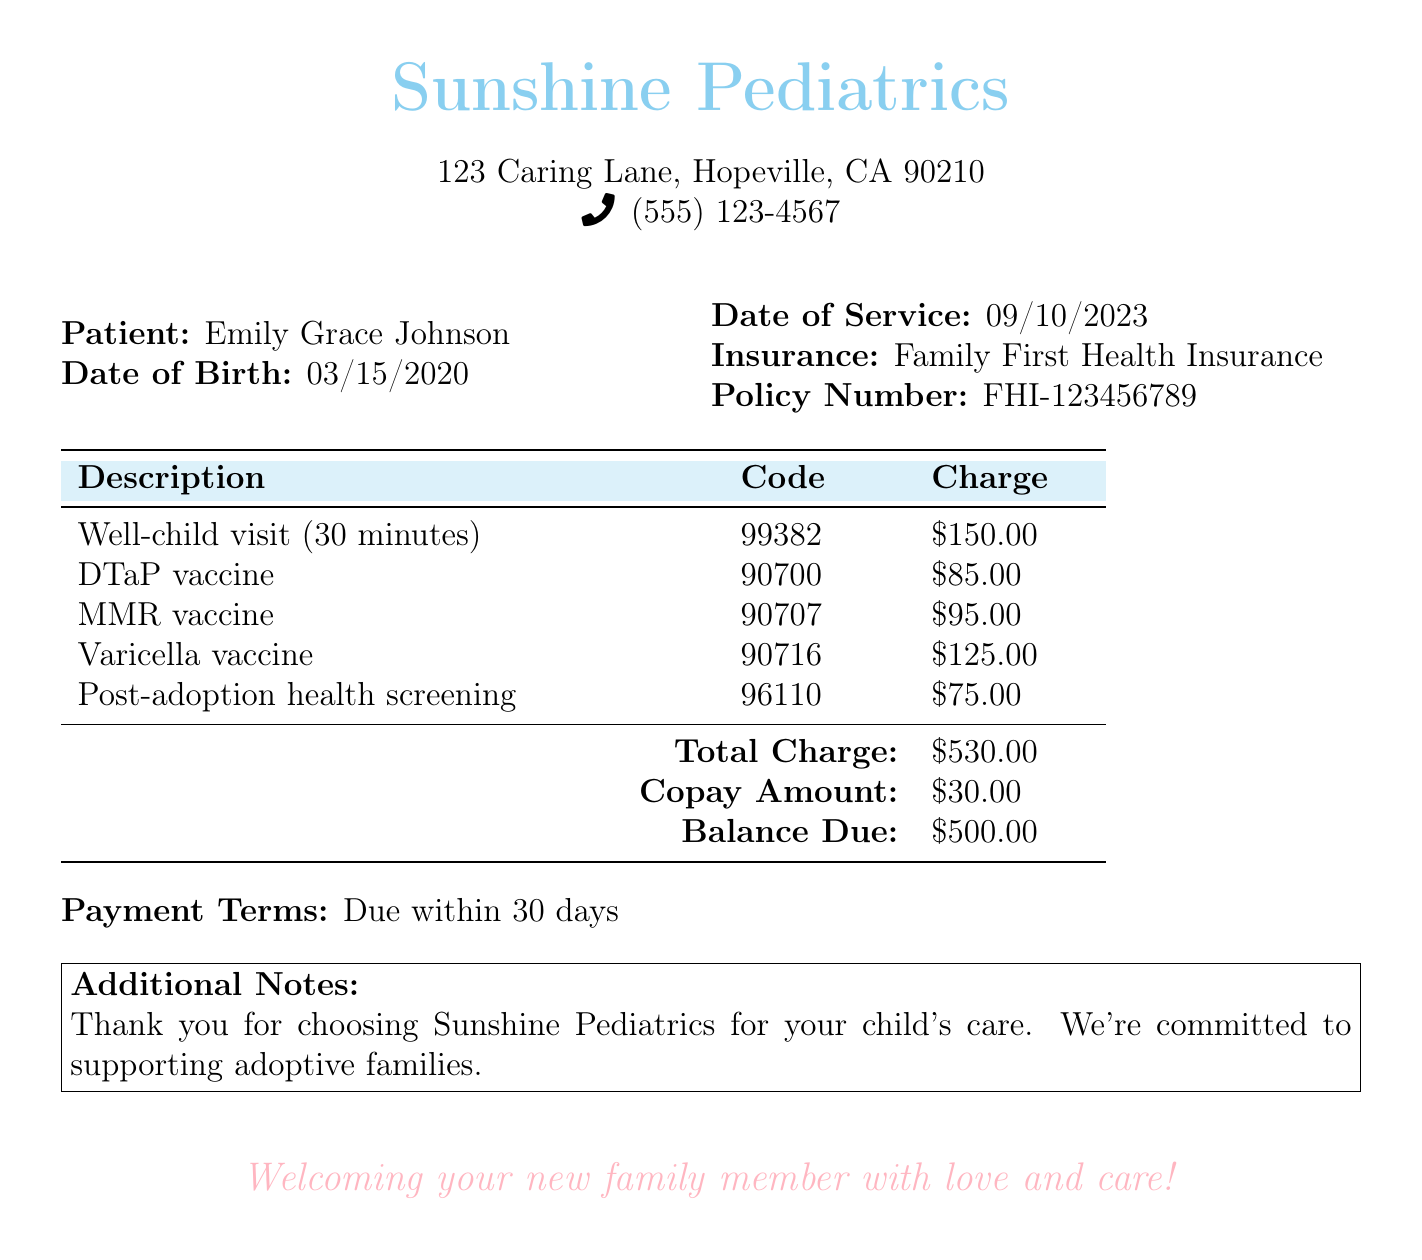What is the name of the patient? The document lists the patient's name as Emily Grace Johnson.
Answer: Emily Grace Johnson What is the date of birth of the patient? The document specifies the date of birth of the patient as March 15, 2020.
Answer: 03/15/2020 What is the total charge for the services? The total charge is provided at the bottom of the services listed in the document.
Answer: $530.00 What is the balance due after copay? The balance due is the amount remaining after subtracting the copay from the total charge.
Answer: $500.00 What are the dates of service? The document indicates the service was provided on September 10, 2023.
Answer: 09/10/2023 What is the insurance company mentioned? The name of the insurance company is listed in the document.
Answer: Family First Health Insurance What is the copay amount? The copay amount is specified in the billing document as part of the payment details.
Answer: $30.00 What is the purpose of the post-adoption health screening? The post-adoption health screening not only diagnoses but also ensures the child's health after being adopted.
Answer: Post-adoption health screening What is the payment term specified in the document? The payment terms detail how long the patient has to pay the bill.
Answer: Due within 30 days 